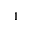Convert formula to latex. <formula><loc_0><loc_0><loc_500><loc_500>1</formula> 